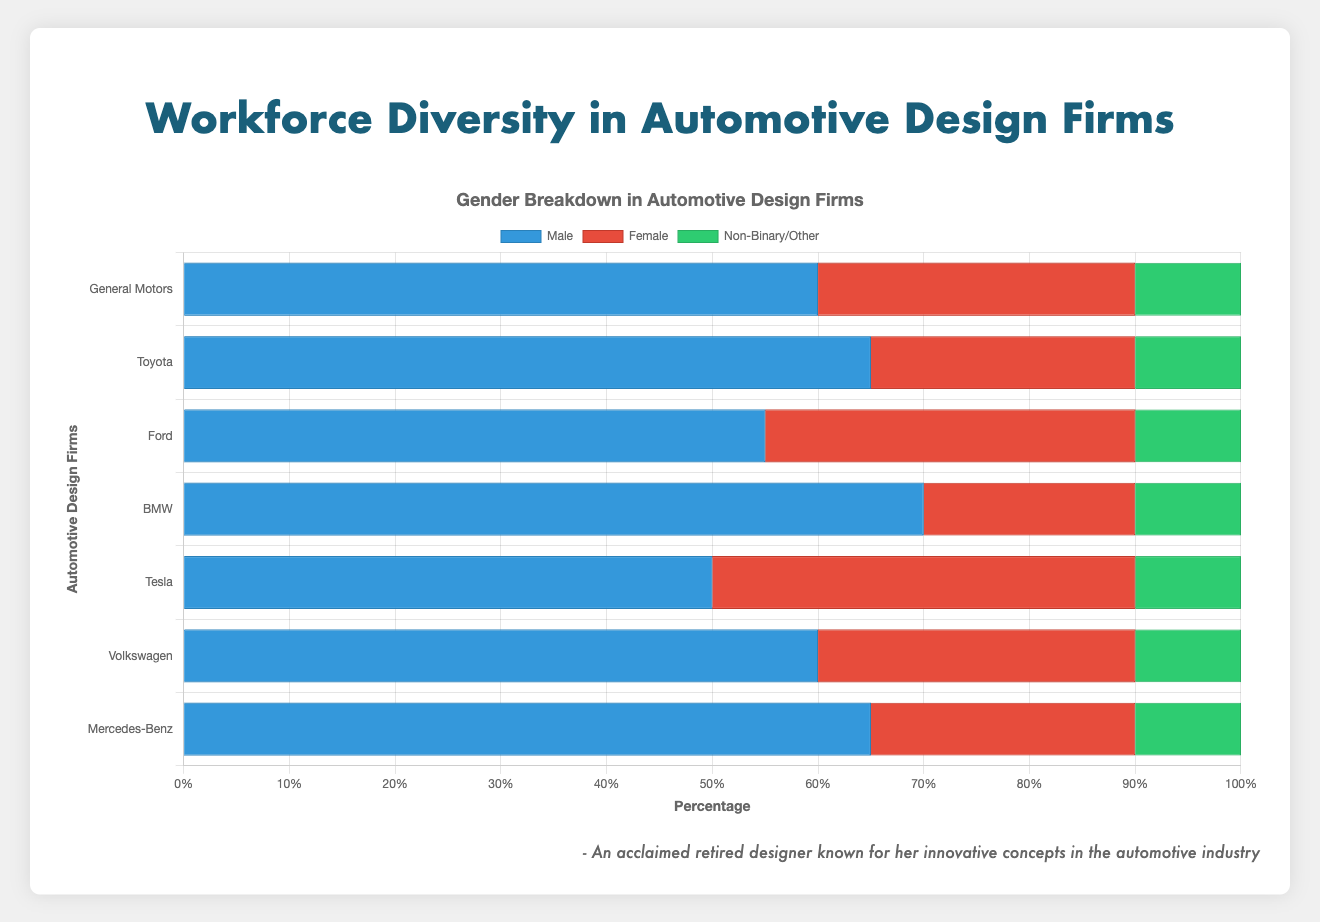Which firm has the highest percentage of male employees? By looking at the lengths of the male bars, BMW has the longest bar followed by Toyota and Mercedes-Benz. Therefore, BMW has the highest percentage.
Answer: BMW What is the combined percentage of female employees in Ford and Tesla? Ford has 35% female employees, and Tesla has 40%. Adding these together, 35 + 40 = 75%.
Answer: 75% Which firm showcases the most balanced gender distribution (closest percentages for each gender)? Tesla has 50% male, 40% female, and 10% non-binary/other, the most balanced compared to the other firms.
Answer: Tesla How does the percentage of non-binary/other employees in General Motors compare to Volkswagen? Both General Motors and Volkswagen have non-binary/other employees at 10%, so their percentages are equal.
Answer: Equal Which firm has a higher percentage of female employees: Ford or BMW? Ford has 35% female employees while BMW has 20%. Thus, Ford has a higher percentage of female employees.
Answer: Ford Summing all the male and female percentages in Mercedes-Benz, what is the total? Mercedes-Benz has 65% males and 25% females. Summing these percentages, 65 + 25 = 90%.
Answer: 90% In Toyota, is the percentage of male employees greater than the combined percentages of female and non-binary/other employees? In Toyota, the male percentage is 65%. The sum of female and non-binary/other employees is 25 + 10 = 35%. Therefore, 65% is greater than 35%.
Answer: Yes Which company shows the lowest diversity in gender? BMW has 70% male, 20% female, and 10% non-binary/other, making it the firm with the most skewed gender distribution.
Answer: BMW Is the percentage of female employees greater in Volkswagen or General Motors? Volkswagen has 30% female employees, while General Motors also has 30%. Both percentages are the same.
Answer: Equal 